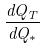<formula> <loc_0><loc_0><loc_500><loc_500>\frac { d Q _ { T } } { d Q _ { * } }</formula> 